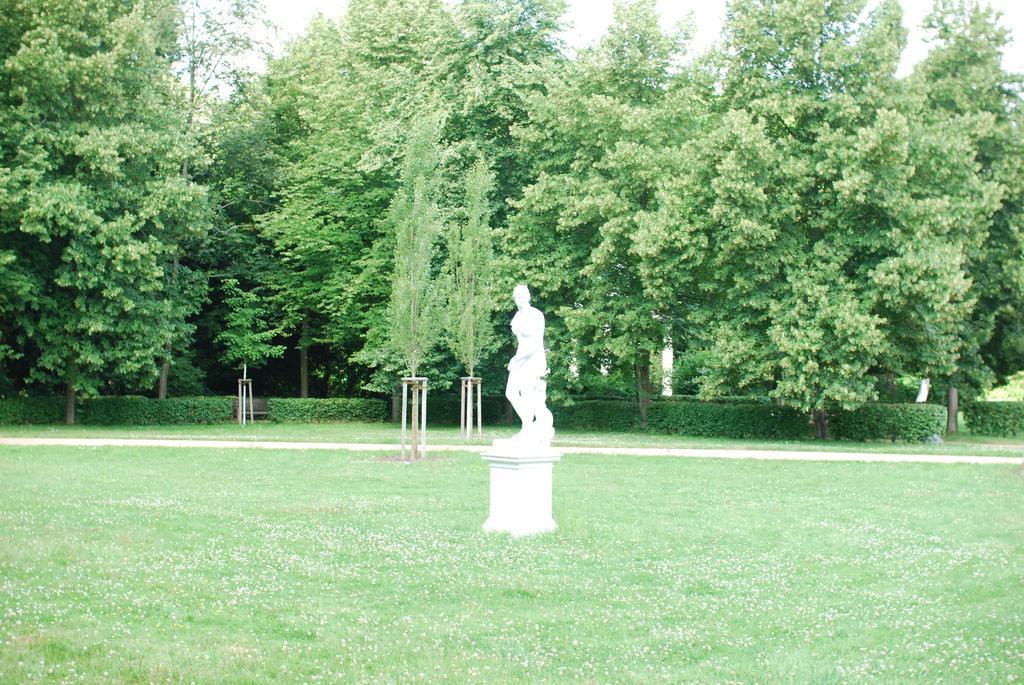In one or two sentences, can you explain what this image depicts? In this image I can see trees and I can see a white color statue on the ground and bushes visible in front of the tree. 